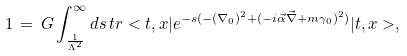<formula> <loc_0><loc_0><loc_500><loc_500>1 \, = \, G \int _ { \frac { 1 } { \Lambda ^ { 2 } } } ^ { \infty } d s \, t r < t , x | e ^ { - s ( - ( \nabla _ { 0 } ) ^ { 2 } + ( - i \vec { \alpha } \vec { \nabla } + m \gamma _ { 0 } ) ^ { 2 } ) } | t , x > ,</formula> 